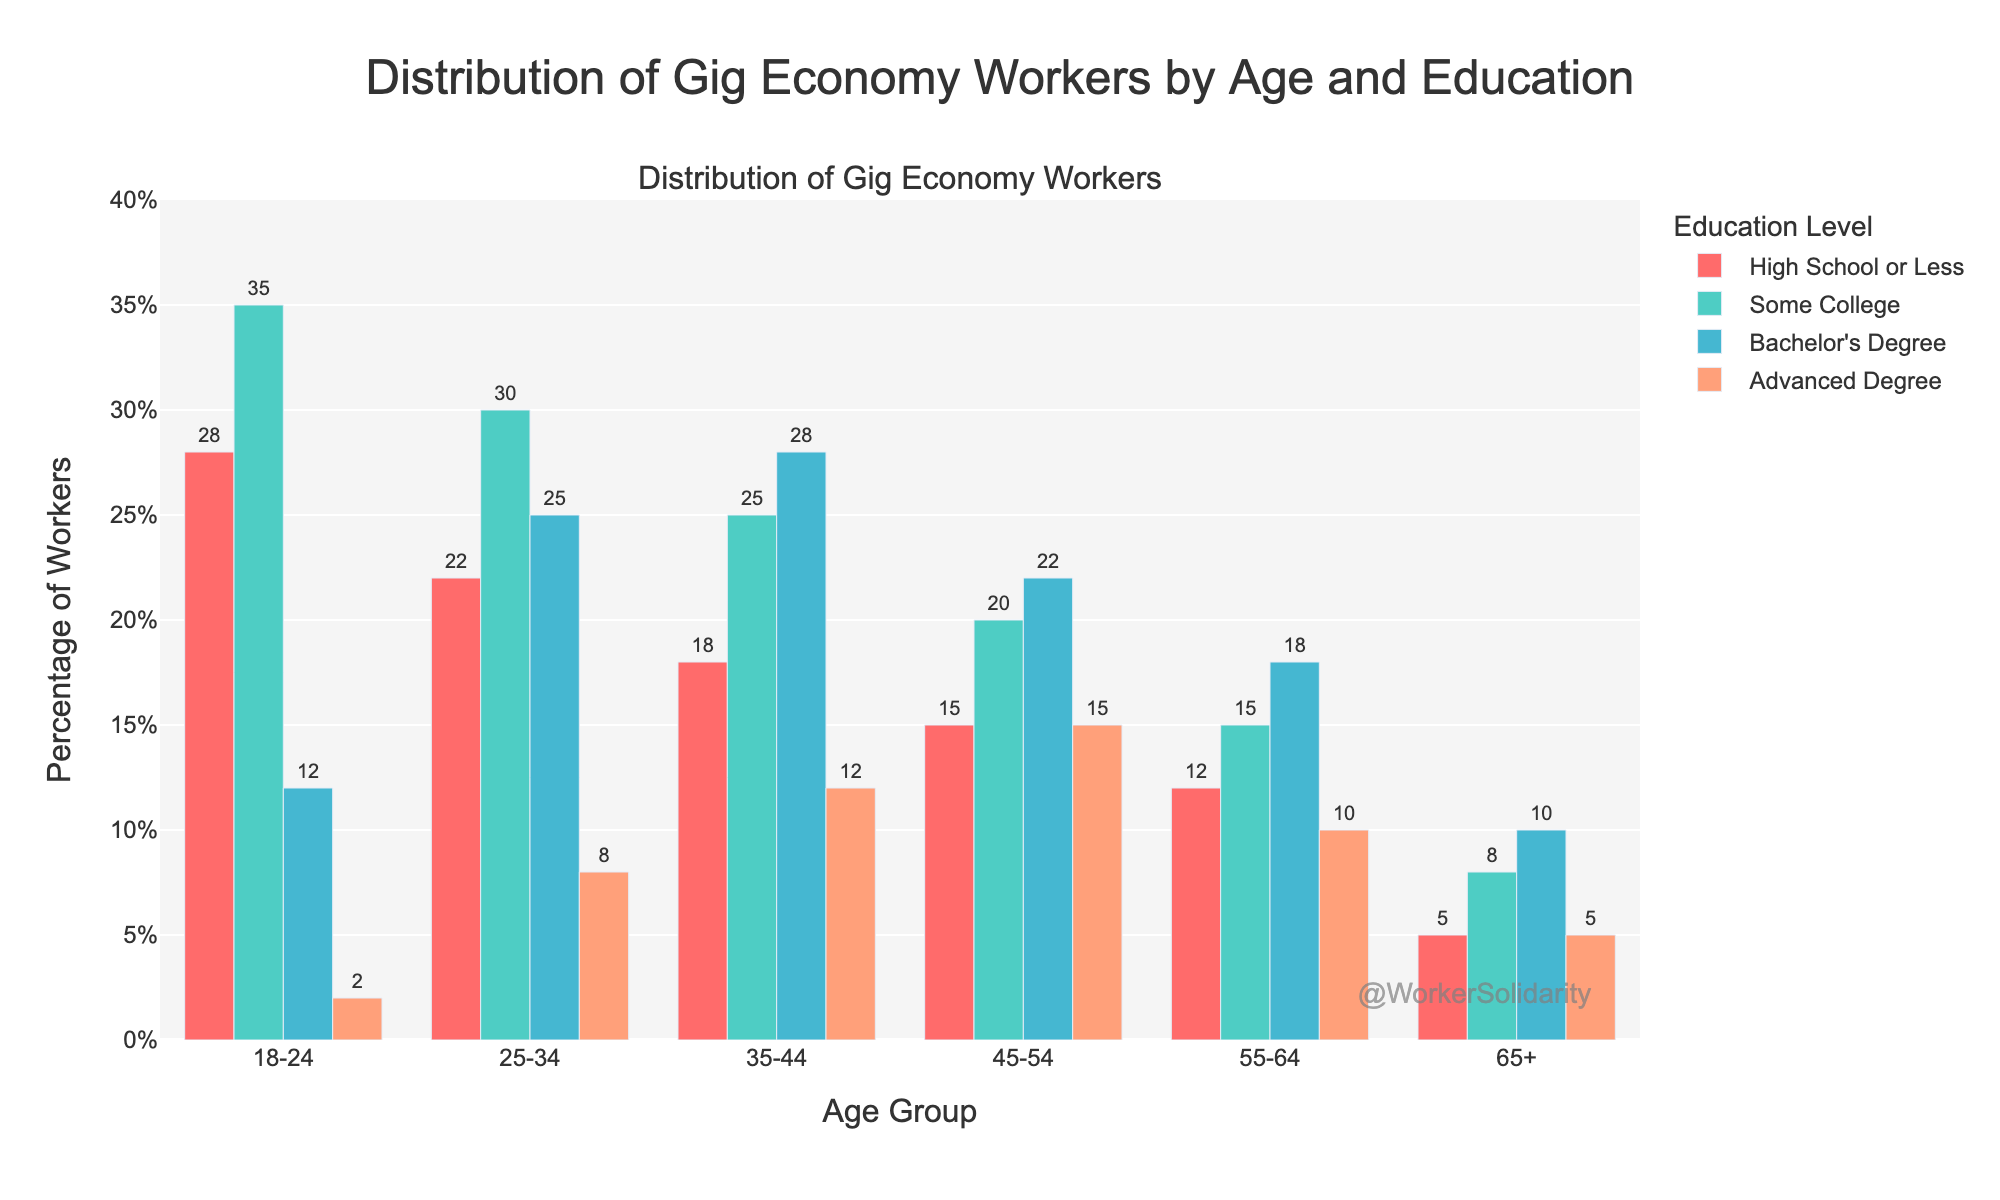What's the highest percentage of gig economy workers in the 25-34 age group for any education level? The 25-34 age group is represented by four bars corresponding to different education levels: High School or Less, Some College, Bachelor's Degree, and Advanced Degree. The highest bar in this group is for Some College, with a value of 30%.
Answer: 30% How does the percentage of gig workers with Bachelor's Degrees change across age groups? Looking at the Bachelor's Degree bars across the different age groups, the values are: 12% for 18-24, 25% for 25-34, 28% for 35-44, 22% for 45-54, 18% for 55-64, and 10% for 65+. The trend shows an increase from 18-24 to 35-44, a slight decrease from 35-44 to 45-54, and a further decrease through older age groups.
Answer: Increases then decreases Which education level has the most consistent percentage of workers across all age groups? To determine this, we compare the percentages for each education level across age groups. High School or Less: 28, 22, 18, 15, 12, 5; Some College: 35, 30, 25, 20, 15, 8; Bachelor's Degree: 12, 25, 28, 22, 18, 10; Advanced Degree: 2, 8, 12, 15, 10, 5. High School or Less shows the most consistency with gradually decreasing values.
Answer: High School or Less In which age group is the percentage of workers with advanced degrees the highest? Reviewing the bars for Advanced Degrees, the percentages across age groups are: 2% for 18-24, 8% for 25-34, 12% for 35-44, 15% for 45-54, 10% for 55-64, and 5% for 65+. The highest value is in the 45-54 age group.
Answer: 45-54 Compare the total percentage for the 18-24 group and the 65+ group. Sum the percentages for each education level within the 18-24 age group: 28 + 35 + 12 + 2 = 77%. For the 65+ group: 5 + 8 + 10 + 5 = 28%.
Answer: 77% vs 28% What is the difference in percentages between the group with the highest number of gig workers and the group with the lowest for High School or Less education level? High School or Less has the following percentages across age groups: 28% for 18-24, 22% for 25-34, 18% for 35-44, 15% for 45-54, 12% for 55-64, and 5% for 65+. The highest value is 28%, and the lowest is 5%. The difference is 28% - 5% = 23%.
Answer: 23% Which age group has the least number of gig workers overall? Sum the percentages for each age group: 
18-24: 77%, 
25-34: 85%, 
35-44: 83%, 
45-54: 72%, 
55-64: 55%, 
65+: 28%. The 65+ age group has the lowest total percentage.
Answer: 65+ Which age group has the highest percentage increase between Bachelor's Degree and Advanced Degree? Reviewing the percentage differences: 
18-24: 12% - 2% = 10%, 
25-34: 25% - 8% = 17%, 
35-44: 28% - 12% = 16%, 
45-54: 22% - 15% = 7%, 
55-64: 18% - 10% = 8%, 
65+: 10% - 5% = 5%. The highest percentage increase is between Bachelor's Degree and Advanced Degree in the 25-34 age group, with an increase of 17%.
Answer: 25-34 